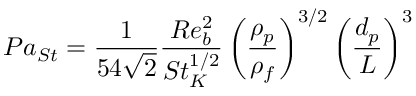Convert formula to latex. <formula><loc_0><loc_0><loc_500><loc_500>P a _ { S t } = \frac { 1 } { 5 4 \sqrt { 2 } } \frac { R e _ { b } ^ { 2 } } { S t _ { K } ^ { 1 / 2 } } \left ( \frac { \rho _ { p } } { \rho _ { f } } \right ) ^ { 3 / 2 } \left ( \frac { d _ { p } } { L } \right ) ^ { 3 }</formula> 